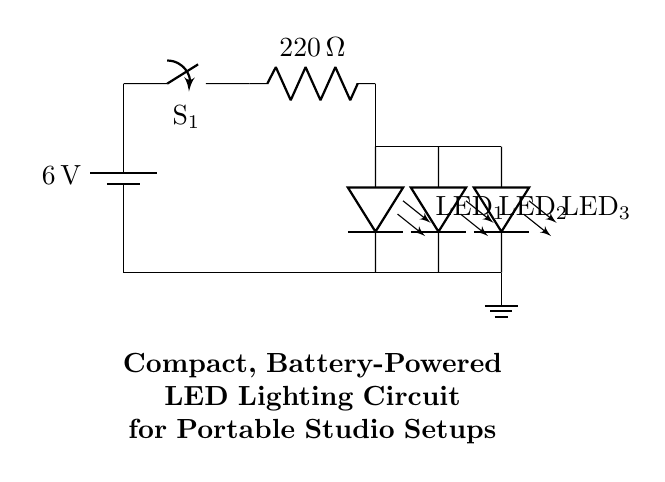What is the voltage of the battery? The battery is labeled as 6 volts in the circuit diagram, indicating the voltage supplied to the circuit.
Answer: 6 volts What type of switch is used in this circuit? The switch is identified as a simple on/off switch labeled S1, which is responsible for controlling the current flow in the circuit.
Answer: A simple switch How many LEDs are used in the circuit? There are three LEDs connected in parallel within the circuit diagram, which can be counted based on the visual representations.
Answer: Three What is the resistance value of the resistor? The resistor is labeled as having a resistance of 220 ohms, which is important for limiting the current flowing through the LEDs.
Answer: 220 ohms What is the connection type of the LEDs? The LEDs are connected in parallel, as indicated by the separate paths that connect to the same voltage source, allowing each LED to operate independently.
Answer: Parallel How does the switch affect the circuit's operation? The switch controls the flow of current to the entire circuit; when the switch is open, no current flows, and hence the LEDs will not light up. When closed, current flows through the circuit, activating the LEDs.
Answer: It turns the circuit on/off What is the purpose of the resistor in this circuit? The resistor limits the current flowing through the LEDs to prevent them from drawing too much current, which could damage them. The appropriate current limit is essential for the safe operation of the LEDs.
Answer: Current limiting 